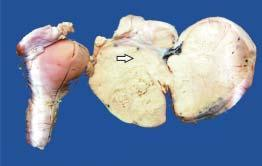what does specimen of the uterus, cervix and adnexa show?
Answer the question using a single word or phrase. Enlarged ovarian mass on one side which on cut section is solid 